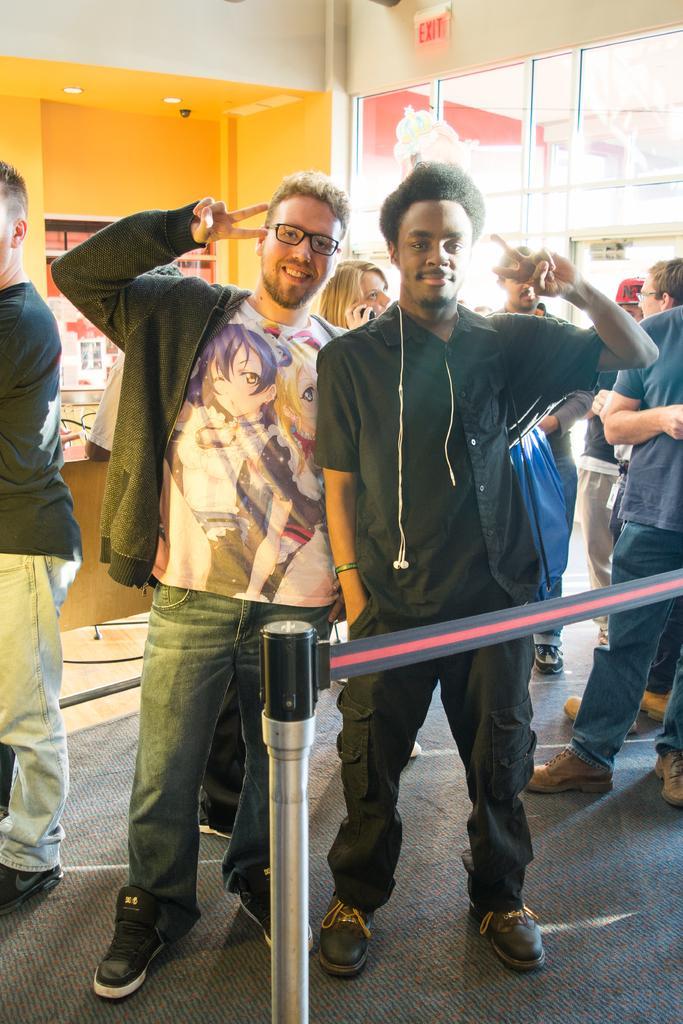Describe this image in one or two sentences. Here we can see few persons standing on the floor. In the background we can see wall, lights, glasses, and a board. 